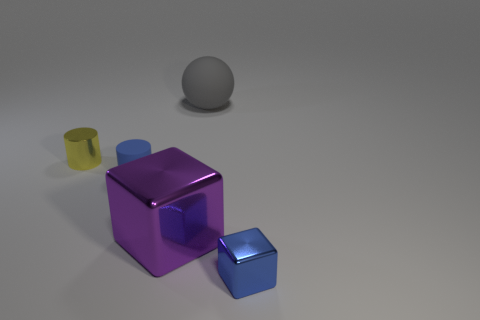Add 5 tiny yellow things. How many objects exist? 10 Subtract all cubes. How many objects are left? 3 Subtract 0 gray cubes. How many objects are left? 5 Subtract all yellow cubes. Subtract all yellow cylinders. How many objects are left? 4 Add 2 purple metal things. How many purple metal things are left? 3 Add 1 small cubes. How many small cubes exist? 2 